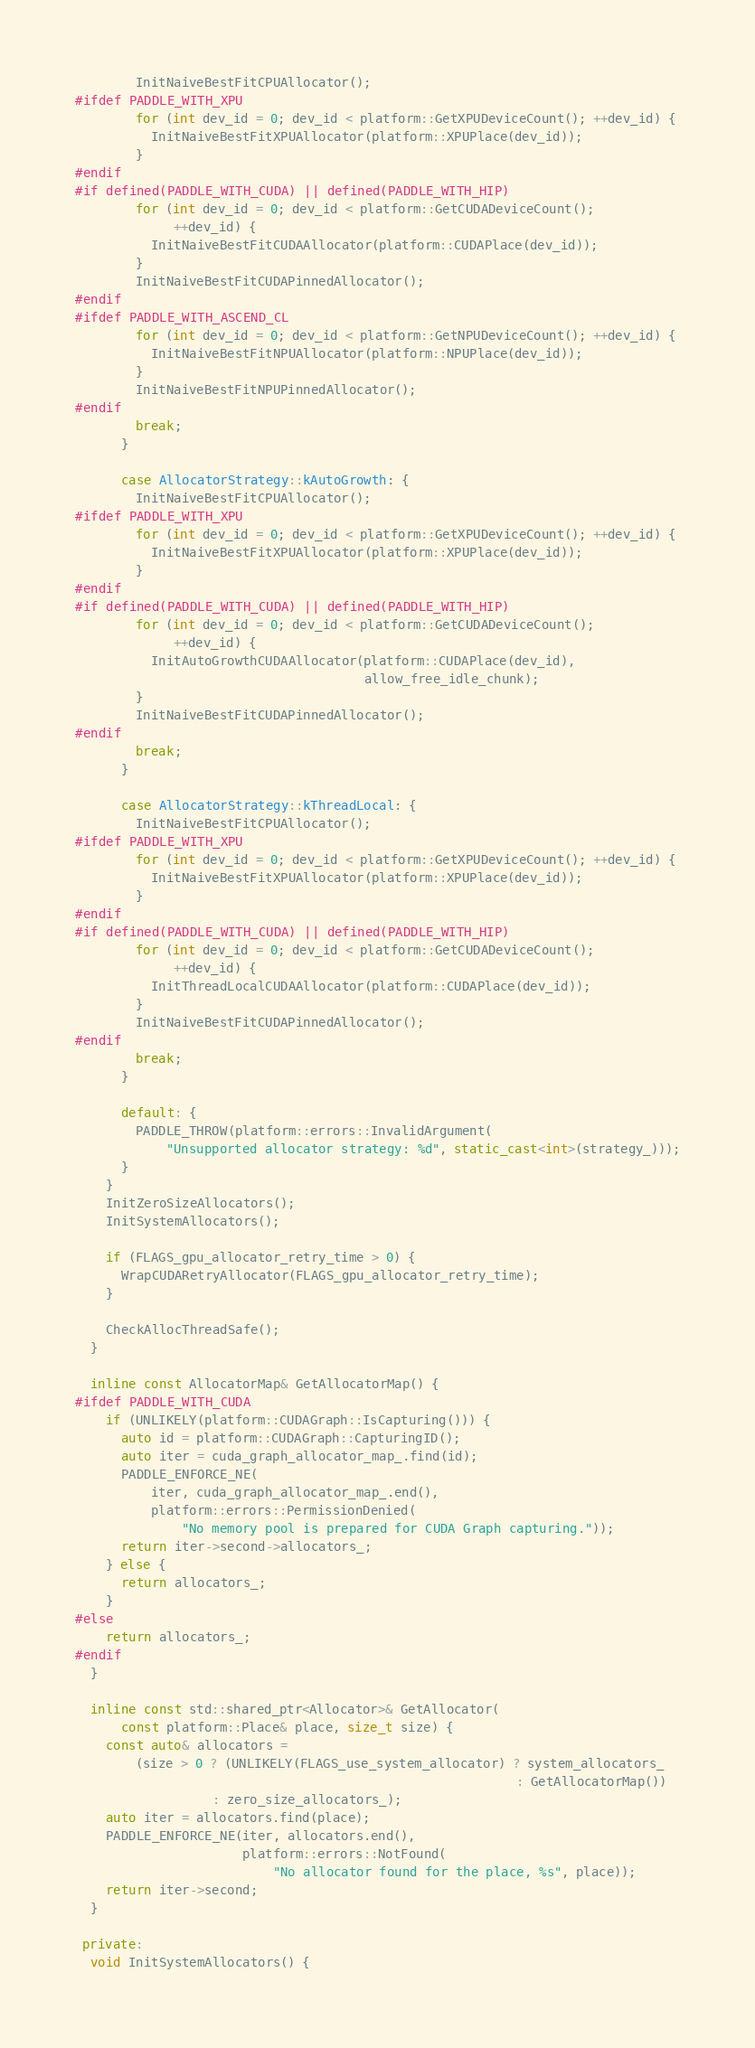Convert code to text. <code><loc_0><loc_0><loc_500><loc_500><_C++_>        InitNaiveBestFitCPUAllocator();
#ifdef PADDLE_WITH_XPU
        for (int dev_id = 0; dev_id < platform::GetXPUDeviceCount(); ++dev_id) {
          InitNaiveBestFitXPUAllocator(platform::XPUPlace(dev_id));
        }
#endif
#if defined(PADDLE_WITH_CUDA) || defined(PADDLE_WITH_HIP)
        for (int dev_id = 0; dev_id < platform::GetCUDADeviceCount();
             ++dev_id) {
          InitNaiveBestFitCUDAAllocator(platform::CUDAPlace(dev_id));
        }
        InitNaiveBestFitCUDAPinnedAllocator();
#endif
#ifdef PADDLE_WITH_ASCEND_CL
        for (int dev_id = 0; dev_id < platform::GetNPUDeviceCount(); ++dev_id) {
          InitNaiveBestFitNPUAllocator(platform::NPUPlace(dev_id));
        }
        InitNaiveBestFitNPUPinnedAllocator();
#endif
        break;
      }

      case AllocatorStrategy::kAutoGrowth: {
        InitNaiveBestFitCPUAllocator();
#ifdef PADDLE_WITH_XPU
        for (int dev_id = 0; dev_id < platform::GetXPUDeviceCount(); ++dev_id) {
          InitNaiveBestFitXPUAllocator(platform::XPUPlace(dev_id));
        }
#endif
#if defined(PADDLE_WITH_CUDA) || defined(PADDLE_WITH_HIP)
        for (int dev_id = 0; dev_id < platform::GetCUDADeviceCount();
             ++dev_id) {
          InitAutoGrowthCUDAAllocator(platform::CUDAPlace(dev_id),
                                      allow_free_idle_chunk);
        }
        InitNaiveBestFitCUDAPinnedAllocator();
#endif
        break;
      }

      case AllocatorStrategy::kThreadLocal: {
        InitNaiveBestFitCPUAllocator();
#ifdef PADDLE_WITH_XPU
        for (int dev_id = 0; dev_id < platform::GetXPUDeviceCount(); ++dev_id) {
          InitNaiveBestFitXPUAllocator(platform::XPUPlace(dev_id));
        }
#endif
#if defined(PADDLE_WITH_CUDA) || defined(PADDLE_WITH_HIP)
        for (int dev_id = 0; dev_id < platform::GetCUDADeviceCount();
             ++dev_id) {
          InitThreadLocalCUDAAllocator(platform::CUDAPlace(dev_id));
        }
        InitNaiveBestFitCUDAPinnedAllocator();
#endif
        break;
      }

      default: {
        PADDLE_THROW(platform::errors::InvalidArgument(
            "Unsupported allocator strategy: %d", static_cast<int>(strategy_)));
      }
    }
    InitZeroSizeAllocators();
    InitSystemAllocators();

    if (FLAGS_gpu_allocator_retry_time > 0) {
      WrapCUDARetryAllocator(FLAGS_gpu_allocator_retry_time);
    }

    CheckAllocThreadSafe();
  }

  inline const AllocatorMap& GetAllocatorMap() {
#ifdef PADDLE_WITH_CUDA
    if (UNLIKELY(platform::CUDAGraph::IsCapturing())) {
      auto id = platform::CUDAGraph::CapturingID();
      auto iter = cuda_graph_allocator_map_.find(id);
      PADDLE_ENFORCE_NE(
          iter, cuda_graph_allocator_map_.end(),
          platform::errors::PermissionDenied(
              "No memory pool is prepared for CUDA Graph capturing."));
      return iter->second->allocators_;
    } else {
      return allocators_;
    }
#else
    return allocators_;
#endif
  }

  inline const std::shared_ptr<Allocator>& GetAllocator(
      const platform::Place& place, size_t size) {
    const auto& allocators =
        (size > 0 ? (UNLIKELY(FLAGS_use_system_allocator) ? system_allocators_
                                                          : GetAllocatorMap())
                  : zero_size_allocators_);
    auto iter = allocators.find(place);
    PADDLE_ENFORCE_NE(iter, allocators.end(),
                      platform::errors::NotFound(
                          "No allocator found for the place, %s", place));
    return iter->second;
  }

 private:
  void InitSystemAllocators() {</code> 